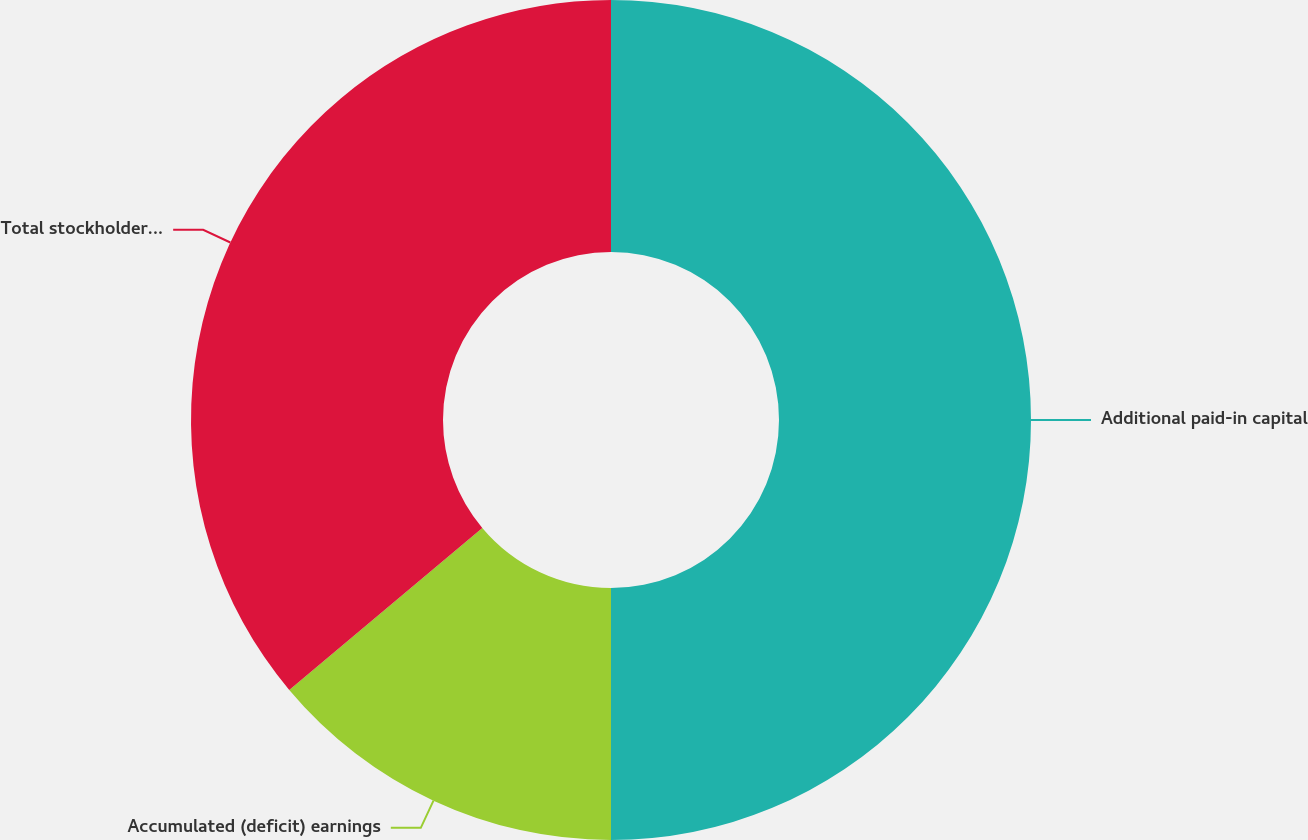Convert chart. <chart><loc_0><loc_0><loc_500><loc_500><pie_chart><fcel>Additional paid-in capital<fcel>Accumulated (deficit) earnings<fcel>Total stockholders' equity<nl><fcel>50.0%<fcel>13.89%<fcel>36.11%<nl></chart> 